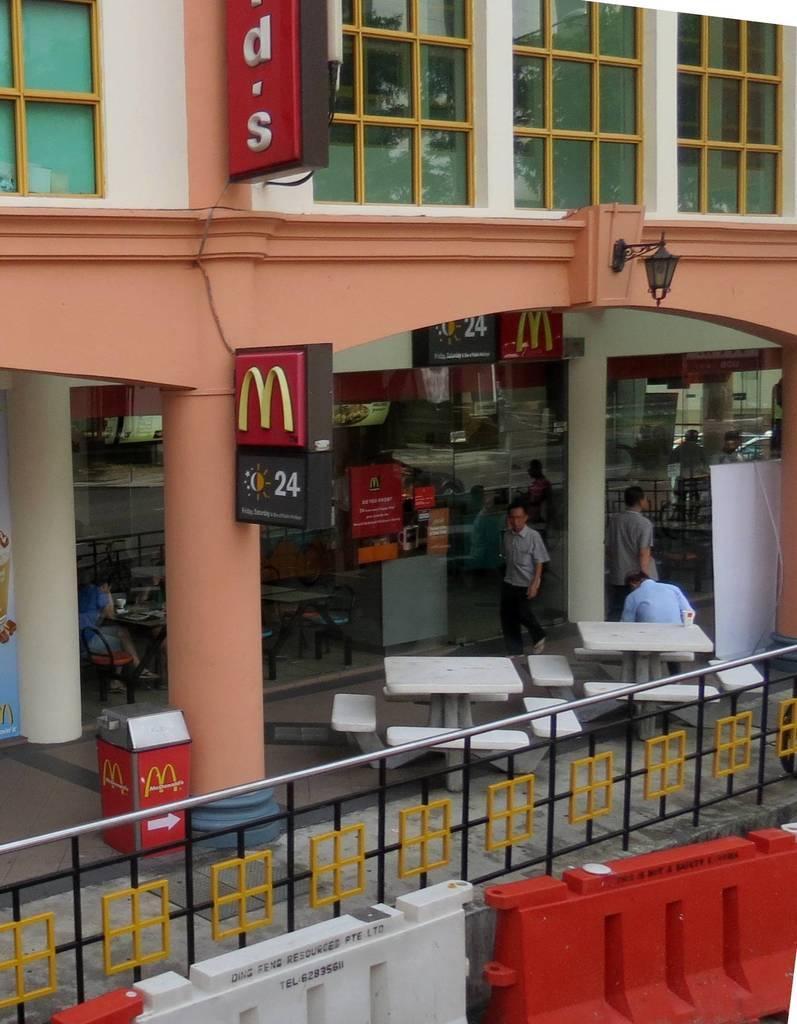In one or two sentences, can you explain what this image depicts? In this picture we can see a building, we can see tables and chairs at the bottom, we can see pillars here, on the left side there is a store, we can see railing in the front, there is a lamp here, we can see a hoarding here. 